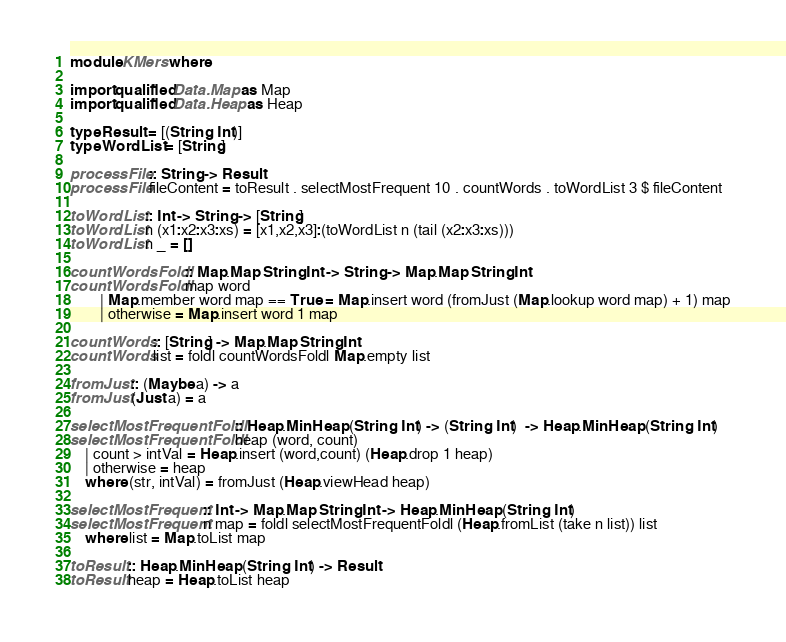Convert code to text. <code><loc_0><loc_0><loc_500><loc_500><_Haskell_>module KMers where

import qualified Data.Map as Map
import qualified Data.Heap as Heap

type Result = [(String, Int)]
type WordList = [String]

processFile :: String -> Result
processFile fileContent = toResult . selectMostFrequent 10 . countWords . toWordList 3 $ fileContent

toWordList :: Int -> String -> [String]
toWordList n (x1:x2:x3:xs) = [x1,x2,x3]:(toWordList n (tail (x2:x3:xs)))
toWordList n _ = []

countWordsFoldl :: Map.Map String Int -> String -> Map.Map String Int
countWordsFoldl map word
        | Map.member word map == True = Map.insert word (fromJust (Map.lookup word map) + 1) map
        | otherwise = Map.insert word 1 map

countWords :: [String] -> Map.Map String Int
countWords list = foldl countWordsFoldl Map.empty list

fromJust :: (Maybe a) -> a
fromJust (Just a) = a

selectMostFrequentFoldl :: Heap.MinHeap (String, Int) -> (String, Int)  -> Heap.MinHeap (String, Int)
selectMostFrequentFoldl heap (word, count)
    | count > intVal = Heap.insert (word,count) (Heap.drop 1 heap)
    | otherwise = heap
    where (str, intVal) = fromJust (Heap.viewHead heap)

selectMostFrequent :: Int -> Map.Map String Int -> Heap.MinHeap (String, Int)
selectMostFrequent n map = foldl selectMostFrequentFoldl (Heap.fromList (take n list)) list
    where list = Map.toList map

toResult :: Heap.MinHeap (String, Int) -> Result
toResult heap = Heap.toList heap</code> 